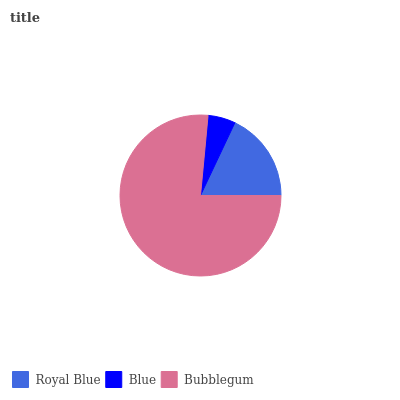Is Blue the minimum?
Answer yes or no. Yes. Is Bubblegum the maximum?
Answer yes or no. Yes. Is Bubblegum the minimum?
Answer yes or no. No. Is Blue the maximum?
Answer yes or no. No. Is Bubblegum greater than Blue?
Answer yes or no. Yes. Is Blue less than Bubblegum?
Answer yes or no. Yes. Is Blue greater than Bubblegum?
Answer yes or no. No. Is Bubblegum less than Blue?
Answer yes or no. No. Is Royal Blue the high median?
Answer yes or no. Yes. Is Royal Blue the low median?
Answer yes or no. Yes. Is Blue the high median?
Answer yes or no. No. Is Blue the low median?
Answer yes or no. No. 